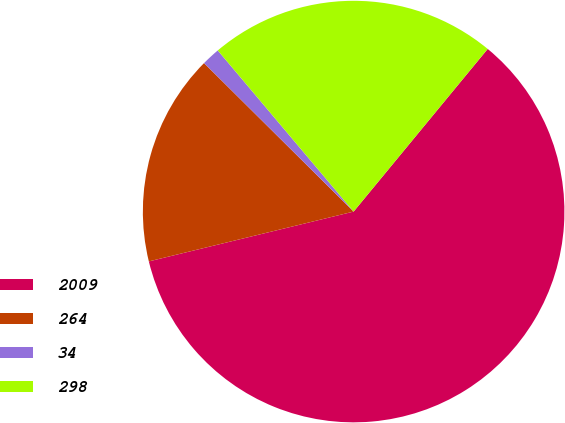Convert chart to OTSL. <chart><loc_0><loc_0><loc_500><loc_500><pie_chart><fcel>2009<fcel>264<fcel>34<fcel>298<nl><fcel>60.23%<fcel>16.24%<fcel>1.41%<fcel>22.12%<nl></chart> 